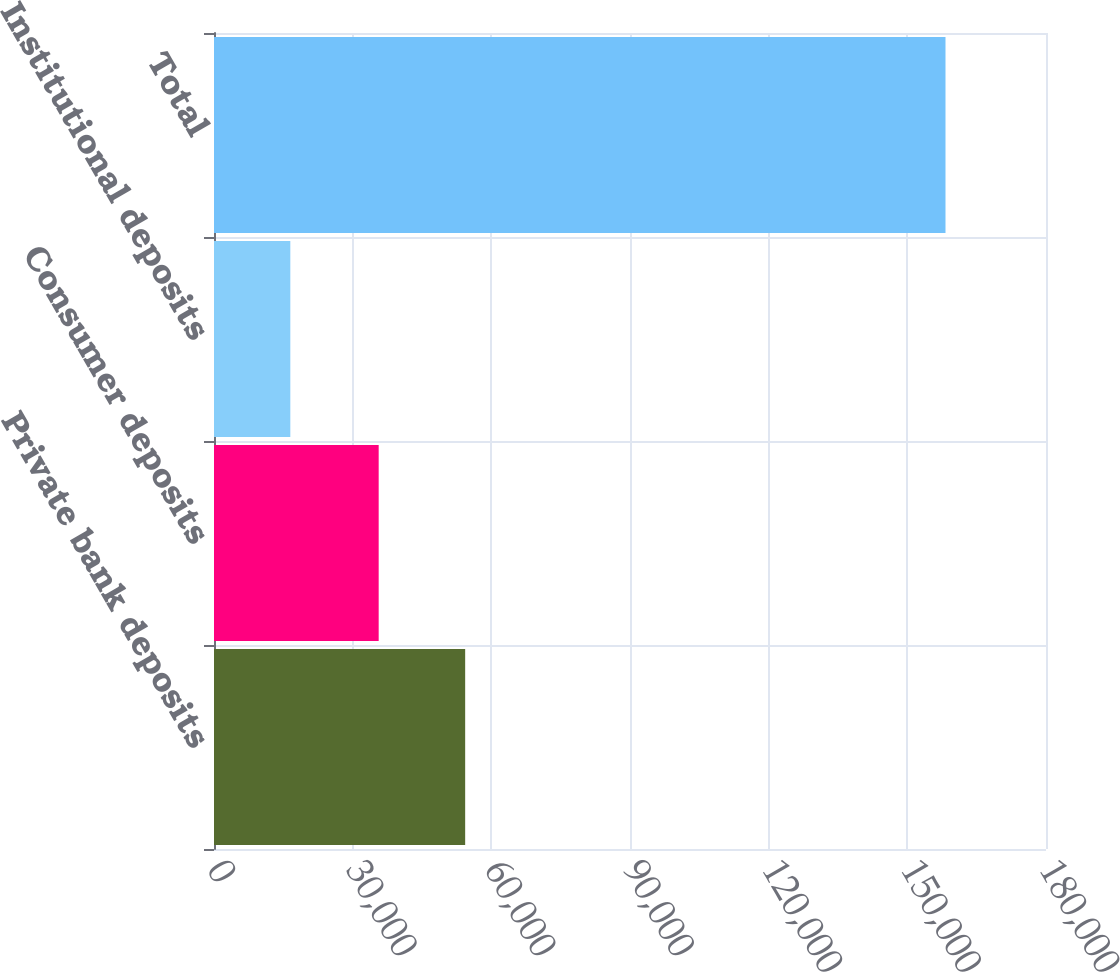Convert chart. <chart><loc_0><loc_0><loc_500><loc_500><bar_chart><fcel>Private bank deposits<fcel>Consumer deposits<fcel>Institutional deposits<fcel>Total<nl><fcel>54339<fcel>35628<fcel>16511<fcel>158257<nl></chart> 